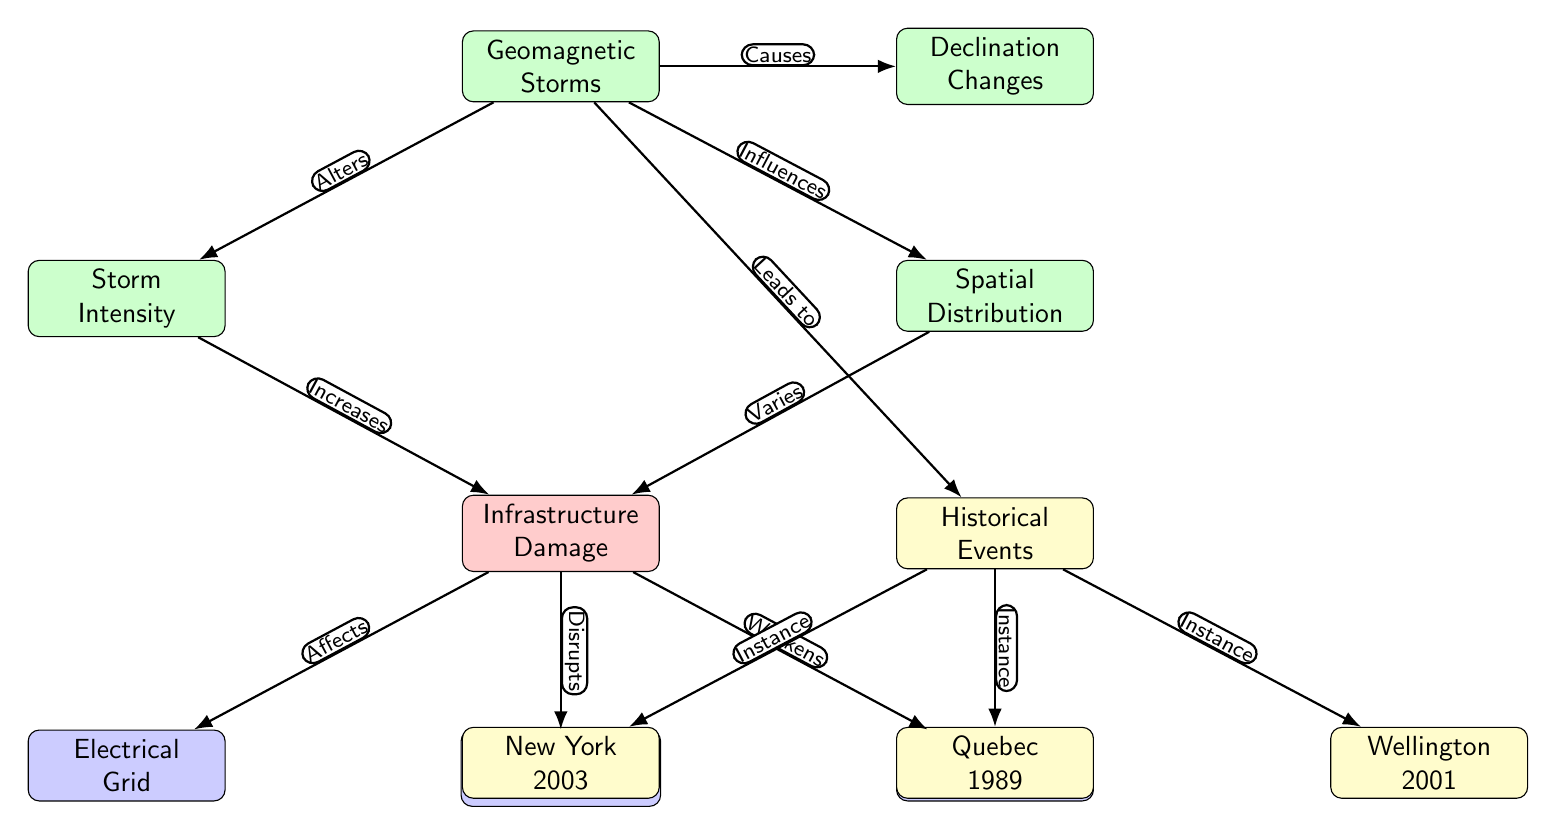What are the three categories of nodes the geomagnetic storms influence? The diagram depicts three categories of nodes affected by geomagnetic storms: electrical grid, communication systems, and home structures, which are categorized under infrastructure damage.
Answer: electrical grid, communication systems, home structures How many historical events are indicated in the diagram? The diagram lists three distinct historical events associated with the impacts of geomagnetic storms: New York 2003, Quebec 1989, and Wellington 2001. Therefore, by counting the labeled events, the total is three.
Answer: 3 What does the geomagnetic storms node lead to? The relationship denoted by the arrow from the geomagnetic storms node shows that it leads to historical events, indicating a direct impact on the occurrences of these events.
Answer: Historical Events Which node describes the types of systems affected by infrastructure damage? The infrastructure damage node branches out to three specific nodes: electrical grid, communication systems, and home structures, detailing the types of systems impacted.
Answer: Electrical grid, communication systems, home structures How does storm intensity relate to infrastructure damage? There is an arrow linking the storm intensity node to the infrastructure damage node, labeled "Increases." This denotes that as storm intensity increases, so does the resulting infrastructure damage.
Answer: Increases Which event instance occurred in 1989? The diagram indicates that Quebec 1989 is one of the historical events resulting from geomagnetic storms, thus serving as the event that occurred in that year.
Answer: Quebec 1989 What is the effect of spatial distribution on infrastructure damage? The diagram connects the spatial distribution node to the infrastructure damage node with the label "Varies," signifying that the impact of infrastructure damage is influenced by how geomagnetic storm spatial distribution varies.
Answer: Varies What are geomagnetic storms classified under? In this diagram, geomagnetic storms are classified as a storm category, depicted by the yellow node at the top.
Answer: Storms 